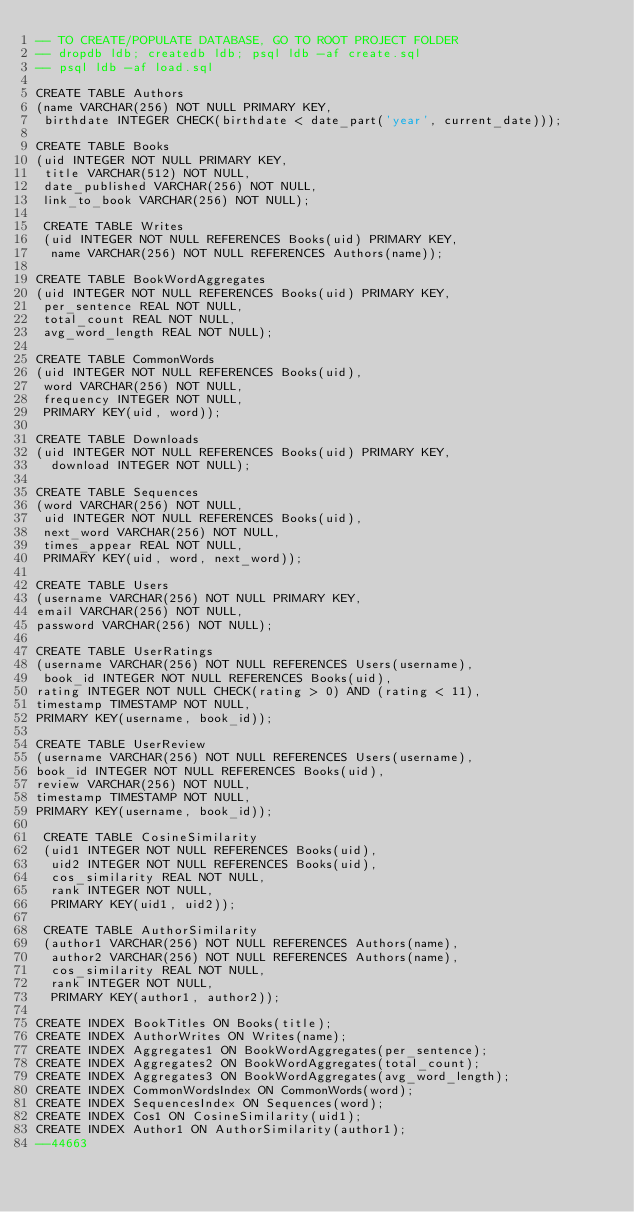<code> <loc_0><loc_0><loc_500><loc_500><_SQL_>-- TO CREATE/POPULATE DATABASE, GO TO ROOT PROJECT FOLDER
-- dropdb ldb; createdb ldb; psql ldb -af create.sql
-- psql ldb -af load.sql

CREATE TABLE Authors
(name VARCHAR(256) NOT NULL PRIMARY KEY,
 birthdate INTEGER CHECK(birthdate < date_part('year', current_date)));

CREATE TABLE Books
(uid INTEGER NOT NULL PRIMARY KEY,
 title VARCHAR(512) NOT NULL,
 date_published VARCHAR(256) NOT NULL,
 link_to_book VARCHAR(256) NOT NULL);

 CREATE TABLE Writes
 (uid INTEGER NOT NULL REFERENCES Books(uid) PRIMARY KEY,
  name VARCHAR(256) NOT NULL REFERENCES Authors(name));

CREATE TABLE BookWordAggregates
(uid INTEGER NOT NULL REFERENCES Books(uid) PRIMARY KEY,
 per_sentence REAL NOT NULL,
 total_count REAL NOT NULL,
 avg_word_length REAL NOT NULL);

CREATE TABLE CommonWords
(uid INTEGER NOT NULL REFERENCES Books(uid),
 word VARCHAR(256) NOT NULL,
 frequency INTEGER NOT NULL,
 PRIMARY KEY(uid, word));

CREATE TABLE Downloads
(uid INTEGER NOT NULL REFERENCES Books(uid) PRIMARY KEY,
  download INTEGER NOT NULL);

CREATE TABLE Sequences
(word VARCHAR(256) NOT NULL,
 uid INTEGER NOT NULL REFERENCES Books(uid),
 next_word VARCHAR(256) NOT NULL,
 times_appear REAL NOT NULL,
 PRIMARY KEY(uid, word, next_word));

CREATE TABLE Users
(username VARCHAR(256) NOT NULL PRIMARY KEY,
email VARCHAR(256) NOT NULL,
password VARCHAR(256) NOT NULL);

CREATE TABLE UserRatings
(username VARCHAR(256) NOT NULL REFERENCES Users(username),
 book_id INTEGER NOT NULL REFERENCES Books(uid),
rating INTEGER NOT NULL CHECK(rating > 0) AND (rating < 11),
timestamp TIMESTAMP NOT NULL,
PRIMARY KEY(username, book_id));

CREATE TABLE UserReview
(username VARCHAR(256) NOT NULL REFERENCES Users(username),
book_id INTEGER NOT NULL REFERENCES Books(uid),
review VARCHAR(256) NOT NULL,
timestamp TIMESTAMP NOT NULL,
PRIMARY KEY(username, book_id));

 CREATE TABLE CosineSimilarity
 (uid1 INTEGER NOT NULL REFERENCES Books(uid),
  uid2 INTEGER NOT NULL REFERENCES Books(uid),
  cos_similarity REAL NOT NULL,
  rank INTEGER NOT NULL,
  PRIMARY KEY(uid1, uid2));

 CREATE TABLE AuthorSimilarity
 (author1 VARCHAR(256) NOT NULL REFERENCES Authors(name),
  author2 VARCHAR(256) NOT NULL REFERENCES Authors(name),
  cos_similarity REAL NOT NULL,
  rank INTEGER NOT NULL,
  PRIMARY KEY(author1, author2));

CREATE INDEX BookTitles ON Books(title);
CREATE INDEX AuthorWrites ON Writes(name);
CREATE INDEX Aggregates1 ON BookWordAggregates(per_sentence);
CREATE INDEX Aggregates2 ON BookWordAggregates(total_count);
CREATE INDEX Aggregates3 ON BookWordAggregates(avg_word_length);
CREATE INDEX CommonWordsIndex ON CommonWords(word);
CREATE INDEX SequencesIndex ON Sequences(word);
CREATE INDEX Cos1 ON CosineSimilarity(uid1);
CREATE INDEX Author1 ON AuthorSimilarity(author1);
--44663
</code> 